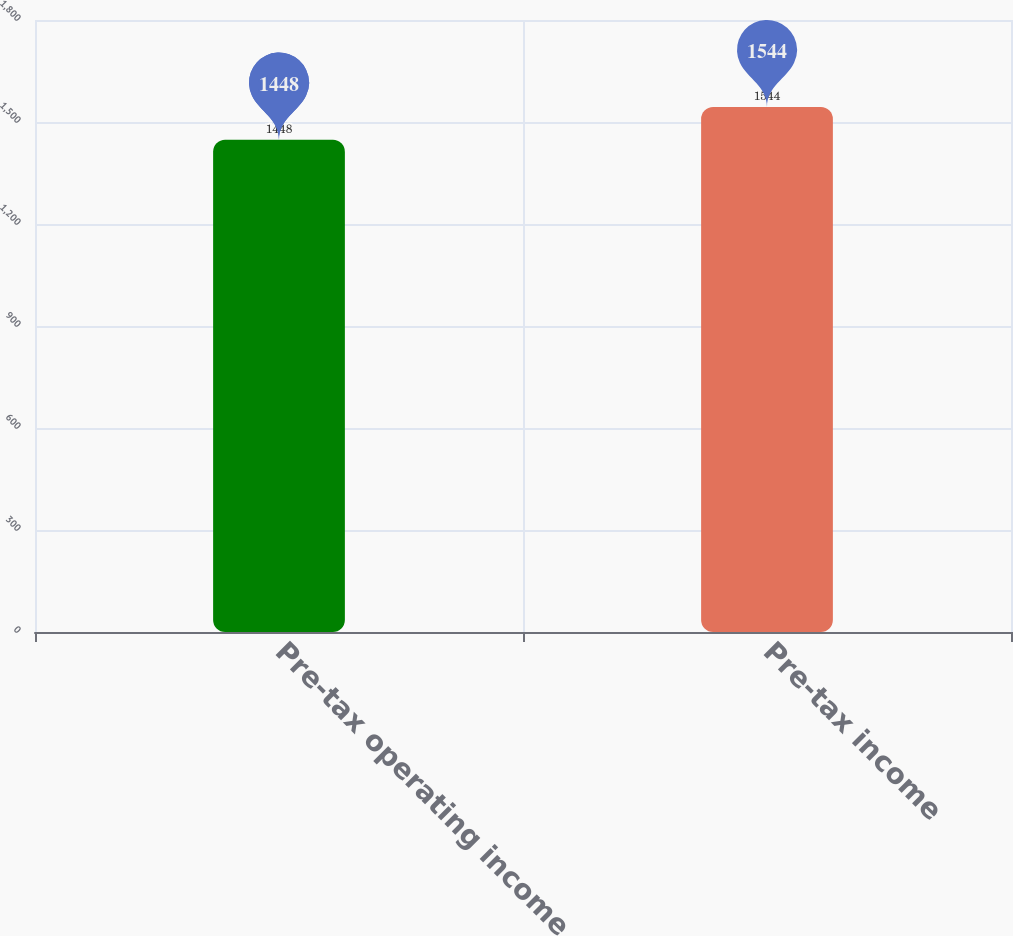Convert chart to OTSL. <chart><loc_0><loc_0><loc_500><loc_500><bar_chart><fcel>Pre-tax operating income<fcel>Pre-tax income<nl><fcel>1448<fcel>1544<nl></chart> 